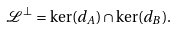<formula> <loc_0><loc_0><loc_500><loc_500>\mathcal { L } ^ { \bot } = \ker ( d _ { A } ) \cap \ker ( d _ { B } ) .</formula> 